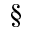Convert formula to latex. <formula><loc_0><loc_0><loc_500><loc_500>\S</formula> 